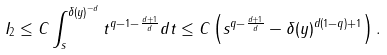Convert formula to latex. <formula><loc_0><loc_0><loc_500><loc_500>I _ { 2 } \leq C \int _ { s } ^ { \delta ( y ) ^ { - d } } t ^ { q - 1 - \frac { d + 1 } { d } } d t \leq C \left ( s ^ { q - \frac { d + 1 } { d } } - \delta ( y ) ^ { d ( 1 - q ) + 1 } \right ) .</formula> 